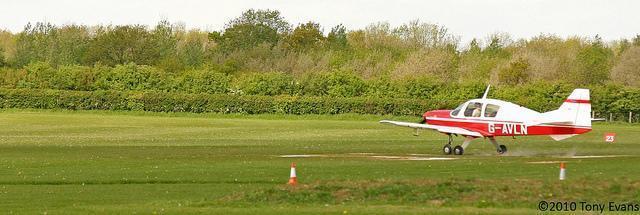How many traffic cones are visible?
Give a very brief answer. 2. How many red cars are there?
Give a very brief answer. 0. 